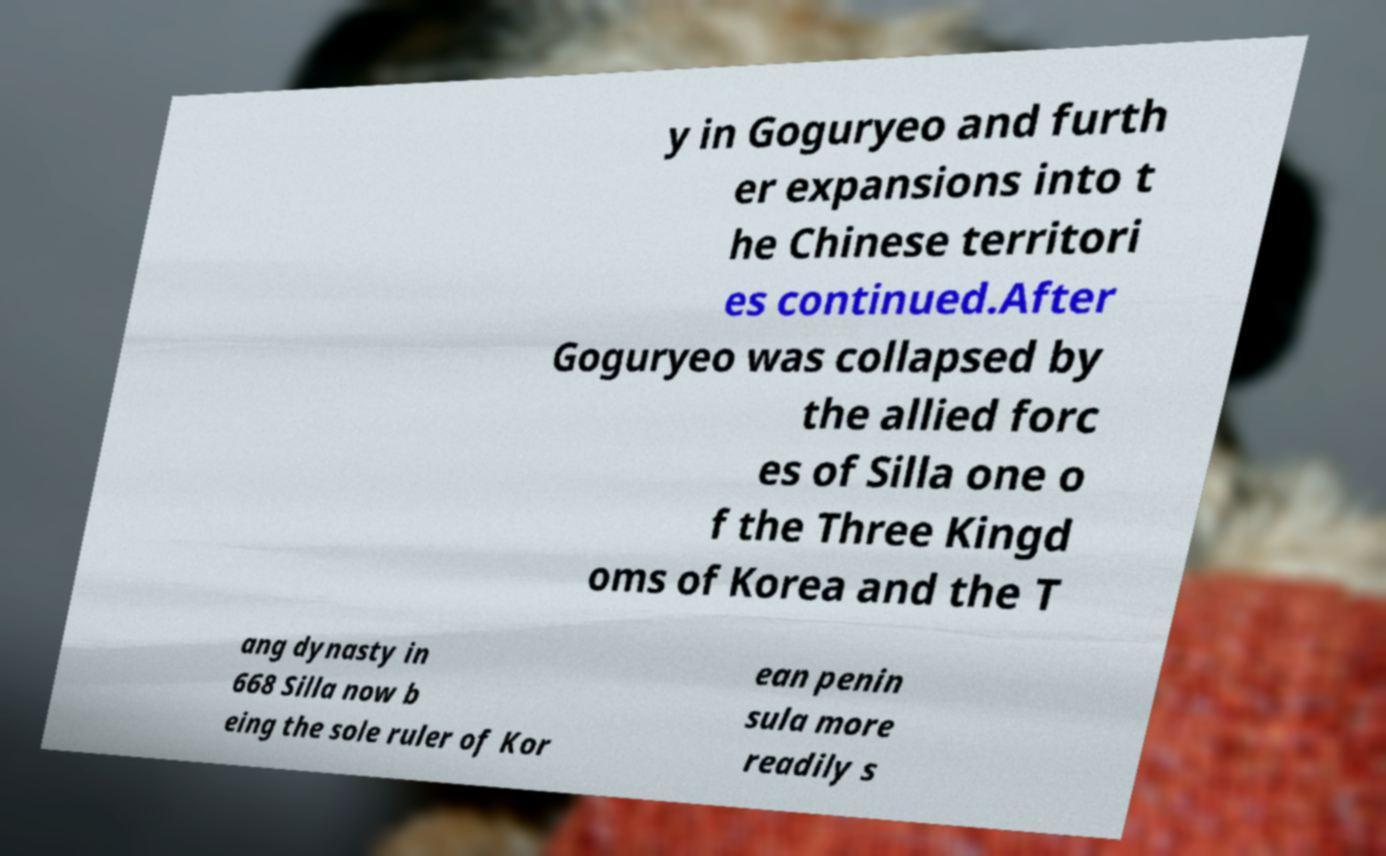Can you read and provide the text displayed in the image?This photo seems to have some interesting text. Can you extract and type it out for me? y in Goguryeo and furth er expansions into t he Chinese territori es continued.After Goguryeo was collapsed by the allied forc es of Silla one o f the Three Kingd oms of Korea and the T ang dynasty in 668 Silla now b eing the sole ruler of Kor ean penin sula more readily s 